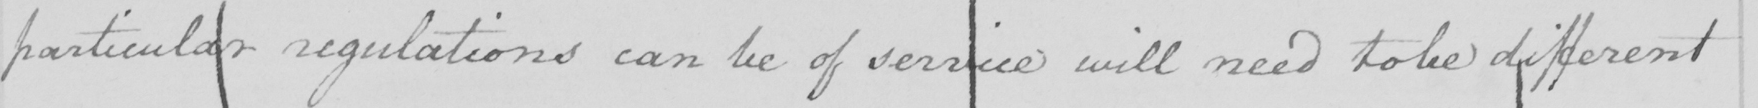Please provide the text content of this handwritten line. particular regulations can be of service will need to be different 